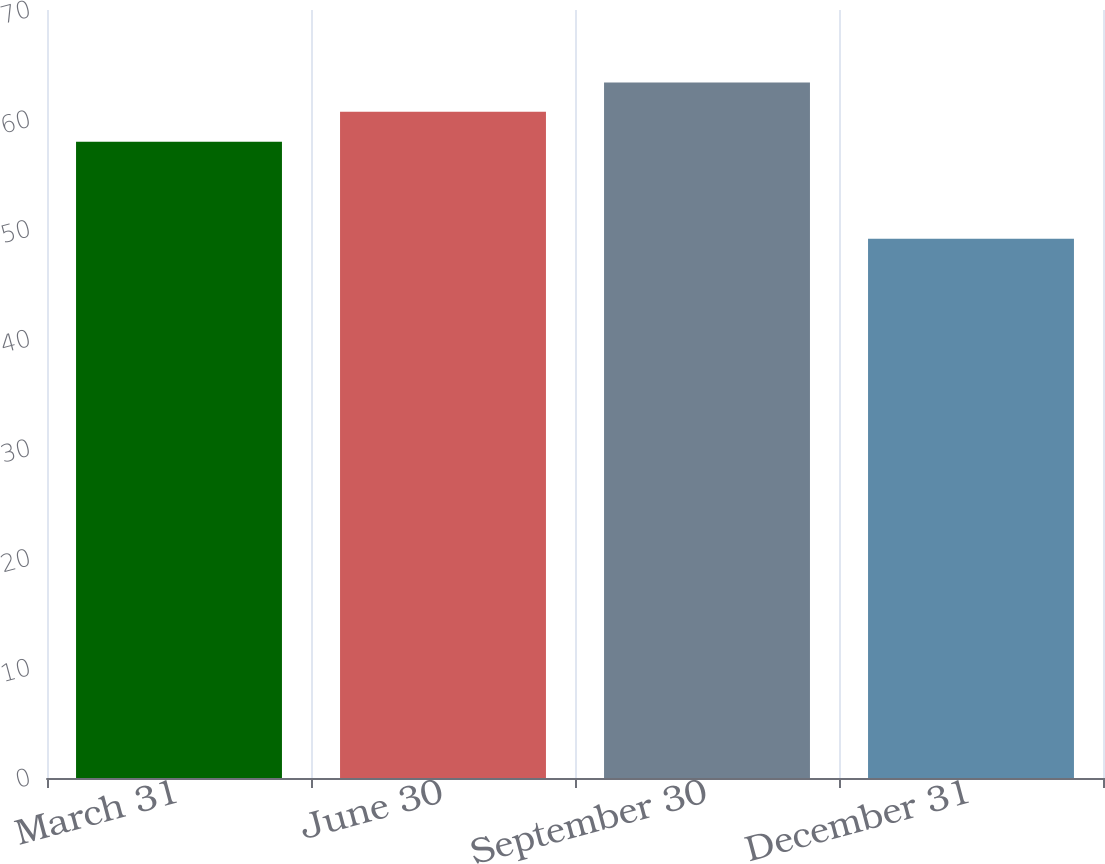<chart> <loc_0><loc_0><loc_500><loc_500><bar_chart><fcel>March 31<fcel>June 30<fcel>September 30<fcel>December 31<nl><fcel>57.99<fcel>60.73<fcel>63.4<fcel>49.15<nl></chart> 